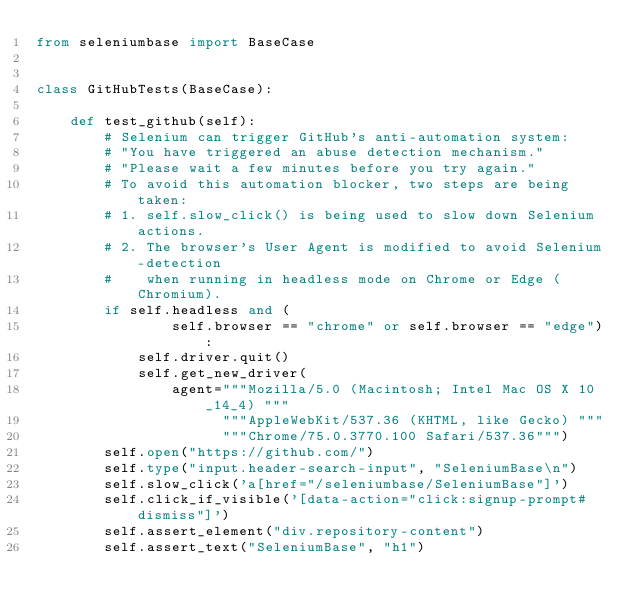Convert code to text. <code><loc_0><loc_0><loc_500><loc_500><_Python_>from seleniumbase import BaseCase


class GitHubTests(BaseCase):

    def test_github(self):
        # Selenium can trigger GitHub's anti-automation system:
        # "You have triggered an abuse detection mechanism."
        # "Please wait a few minutes before you try again."
        # To avoid this automation blocker, two steps are being taken:
        # 1. self.slow_click() is being used to slow down Selenium actions.
        # 2. The browser's User Agent is modified to avoid Selenium-detection
        #    when running in headless mode on Chrome or Edge (Chromium).
        if self.headless and (
                self.browser == "chrome" or self.browser == "edge"):
            self.driver.quit()
            self.get_new_driver(
                agent="""Mozilla/5.0 (Macintosh; Intel Mac OS X 10_14_4) """
                      """AppleWebKit/537.36 (KHTML, like Gecko) """
                      """Chrome/75.0.3770.100 Safari/537.36""")
        self.open("https://github.com/")
        self.type("input.header-search-input", "SeleniumBase\n")
        self.slow_click('a[href="/seleniumbase/SeleniumBase"]')
        self.click_if_visible('[data-action="click:signup-prompt#dismiss"]')
        self.assert_element("div.repository-content")
        self.assert_text("SeleniumBase", "h1")</code> 